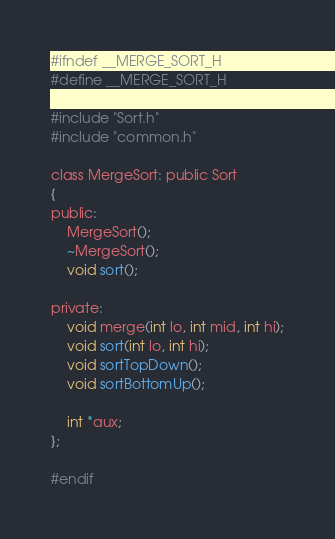<code> <loc_0><loc_0><loc_500><loc_500><_C_>#ifndef __MERGE_SORT_H
#define __MERGE_SORT_H

#include "Sort.h"
#include "common.h"

class MergeSort: public Sort
{
public:
    MergeSort();
    ~MergeSort();
    void sort();

private:
    void merge(int lo, int mid, int hi);
    void sort(int lo, int hi);
    void sortTopDown();
    void sortBottomUp();

    int *aux;
};

#endif

</code> 